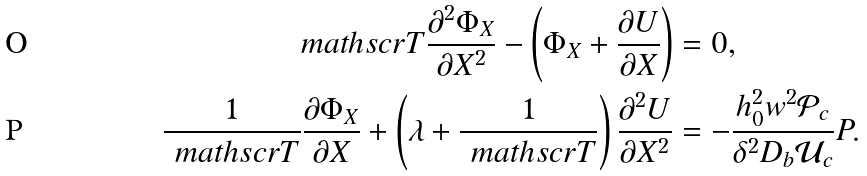Convert formula to latex. <formula><loc_0><loc_0><loc_500><loc_500>\ m a t h s c r { T } \frac { \partial ^ { 2 } \Phi _ { X } } { \partial X ^ { 2 } } - \left ( \Phi _ { X } + \frac { \partial U } { \partial X } \right ) & = 0 , \\ \frac { 1 } { \ m a t h s c r { T } } \frac { \partial \Phi _ { X } } { \partial X } + \left ( \lambda + \frac { 1 } { \ m a t h s c r { T } } \right ) \frac { \partial ^ { 2 } U } { \partial X ^ { 2 } } & = - \frac { h _ { 0 } ^ { 2 } w ^ { 2 } \mathcal { P } _ { c } } { \delta ^ { 2 } D _ { b } \mathcal { U } _ { c } } P .</formula> 